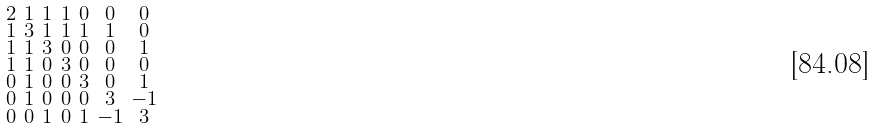Convert formula to latex. <formula><loc_0><loc_0><loc_500><loc_500>\begin{smallmatrix} 2 & 1 & 1 & 1 & 0 & 0 & 0 \\ 1 & 3 & 1 & 1 & 1 & 1 & 0 \\ 1 & 1 & 3 & 0 & 0 & 0 & 1 \\ 1 & 1 & 0 & 3 & 0 & 0 & 0 \\ 0 & 1 & 0 & 0 & 3 & 0 & 1 \\ 0 & 1 & 0 & 0 & 0 & 3 & - 1 \\ 0 & 0 & 1 & 0 & 1 & - 1 & 3 \end{smallmatrix}</formula> 